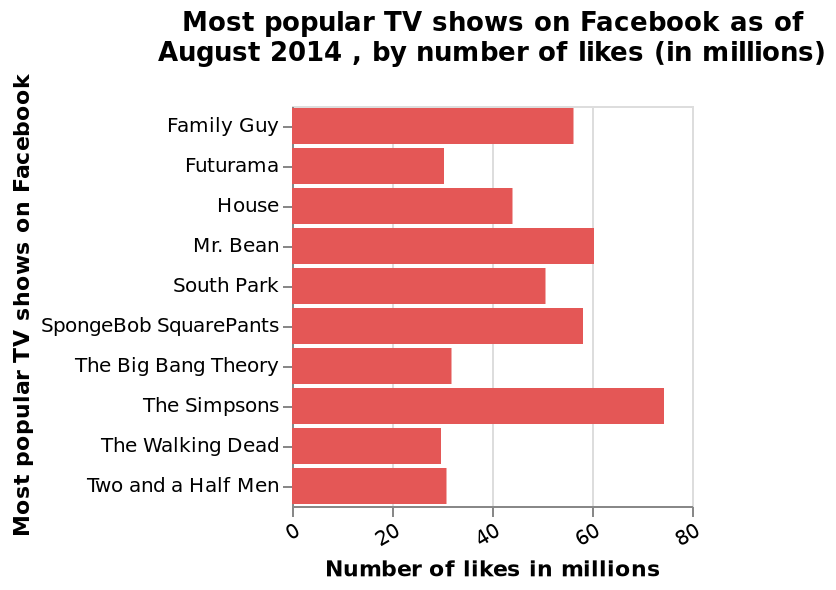<image>
What is the average number of likes for shows on Netflix?  The average number of likes for shows on Netflix appears to be between 40-50 million. 